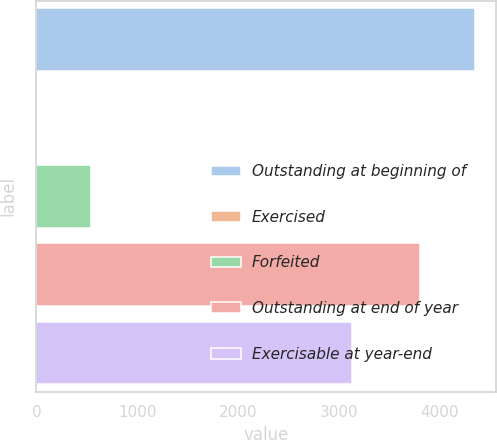Convert chart to OTSL. <chart><loc_0><loc_0><loc_500><loc_500><bar_chart><fcel>Outstanding at beginning of<fcel>Exercised<fcel>Forfeited<fcel>Outstanding at end of year<fcel>Exercisable at year-end<nl><fcel>4347<fcel>2<fcel>542<fcel>3803<fcel>3133<nl></chart> 